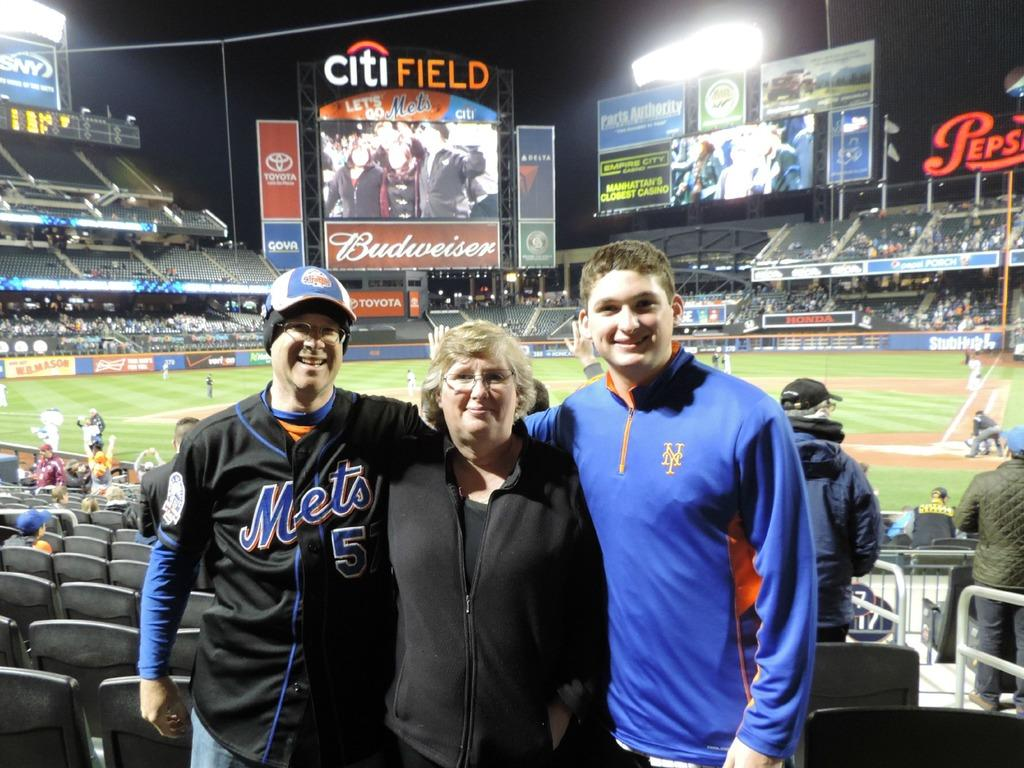<image>
Create a compact narrative representing the image presented. a person wearing a Mets jersey next to his family 